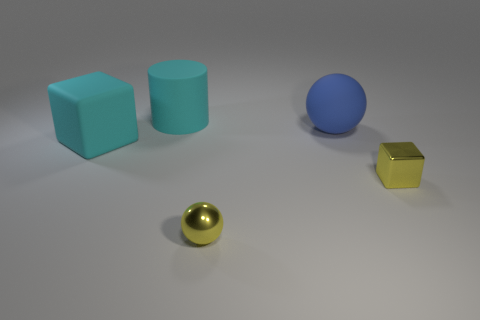Add 4 cubes. How many objects exist? 9 Add 1 yellow shiny spheres. How many yellow shiny spheres are left? 2 Add 4 tiny cyan rubber blocks. How many tiny cyan rubber blocks exist? 4 Subtract 1 yellow balls. How many objects are left? 4 Subtract all balls. How many objects are left? 3 Subtract all large cylinders. Subtract all large blue rubber spheres. How many objects are left? 3 